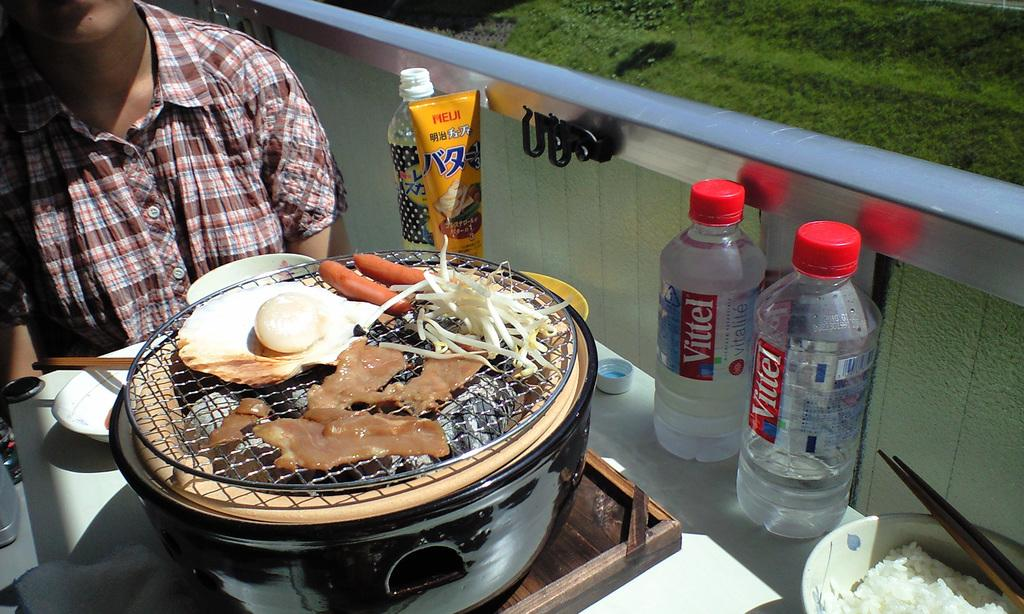<image>
Offer a succinct explanation of the picture presented. Two bottels of Vittel are sitting next to a grill. 